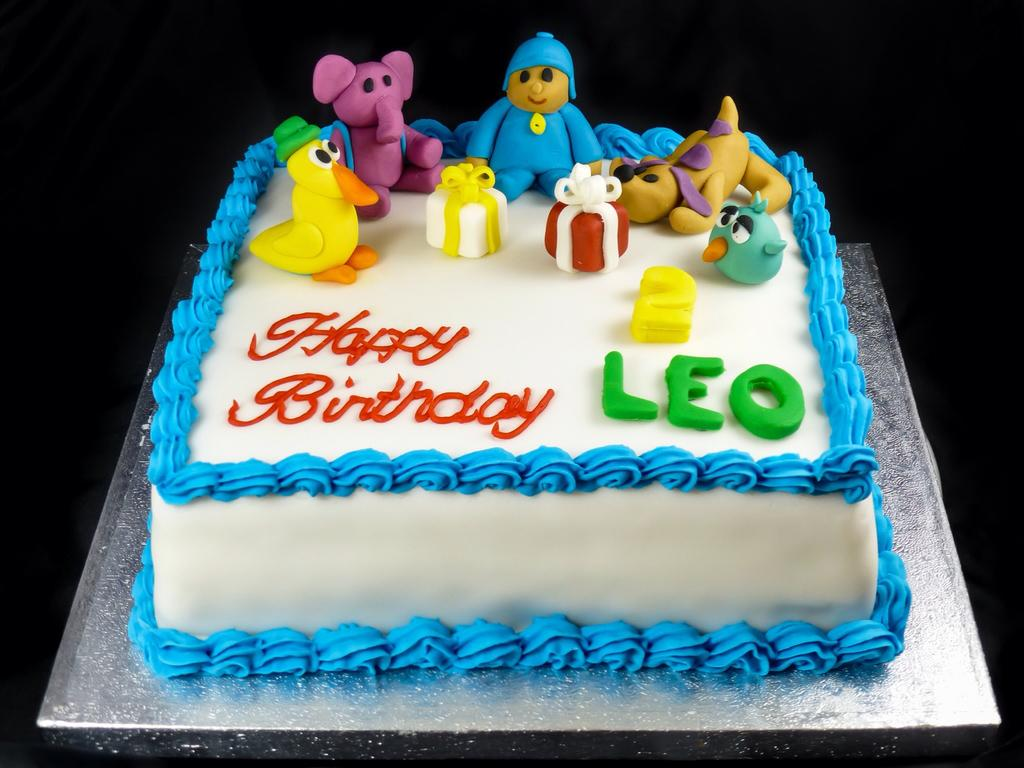What is the main subject of the image? There is a cake in the image. How many colors can be seen on the cake? The cake has multiple colors, including white, blue, yellow, green, red, purple, and light brown. Is there any text on the cake? Yes, there is text written on the cake. What can be observed about the background of the image? The background of the image is dark. What type of seat is visible in the image? There is no seat present in the image; it features a cake with multiple colors and text. What attraction can be seen in the image? There is no attraction present in the image; it features a cake with multiple colors and text. 